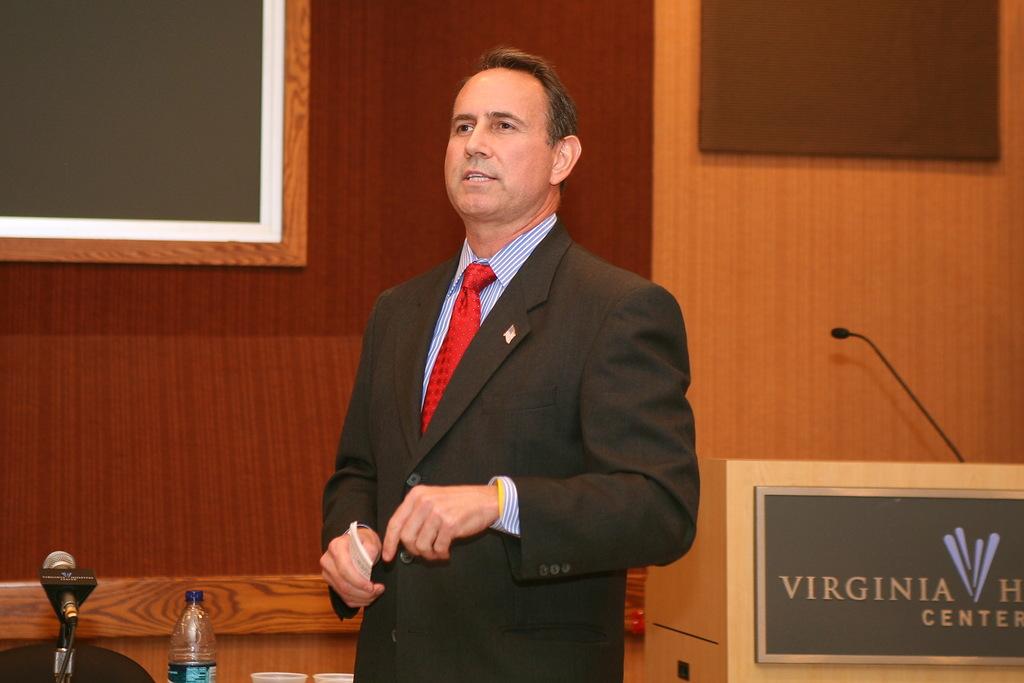Which state is named on the sign in front of the microphone?
Give a very brief answer. Virginia. 